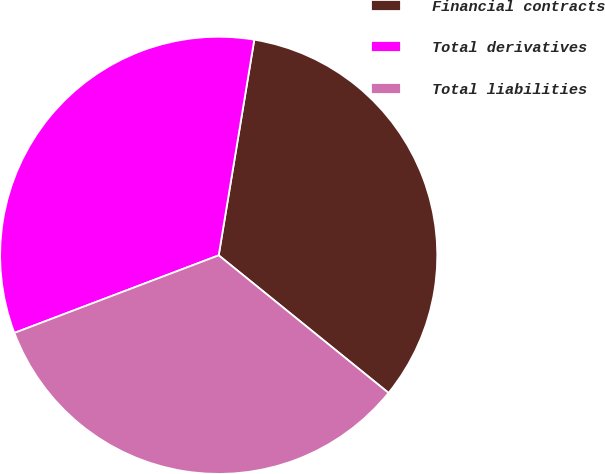<chart> <loc_0><loc_0><loc_500><loc_500><pie_chart><fcel>Financial contracts<fcel>Total derivatives<fcel>Total liabilities<nl><fcel>33.23%<fcel>33.38%<fcel>33.39%<nl></chart> 